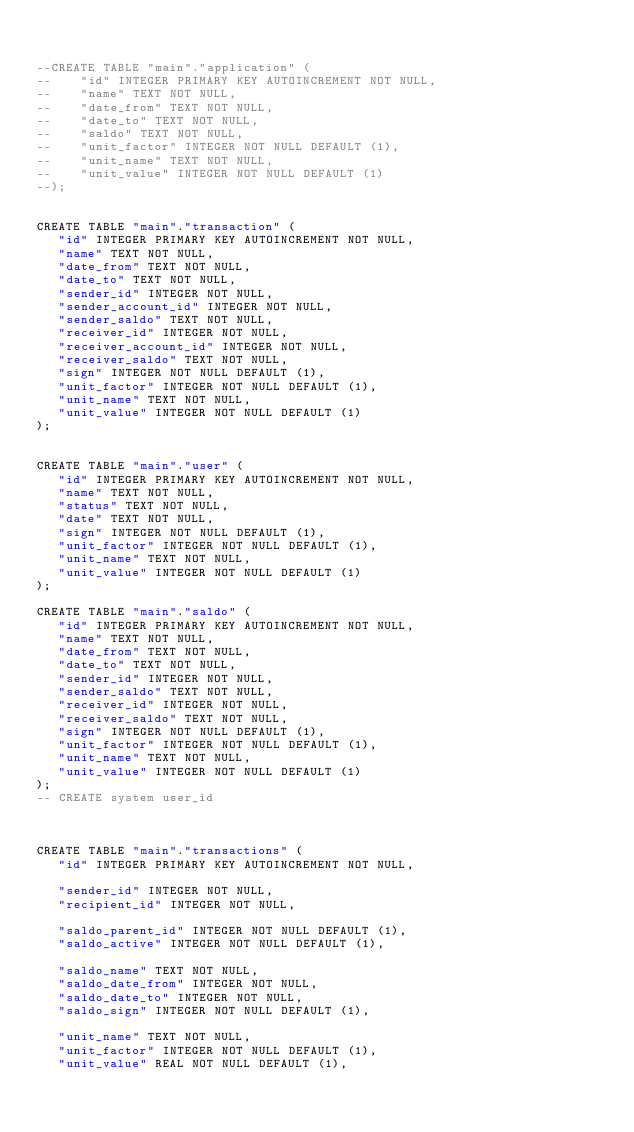Convert code to text. <code><loc_0><loc_0><loc_500><loc_500><_SQL_>

--CREATE TABLE "main"."application" (
--    "id" INTEGER PRIMARY KEY AUTOINCREMENT NOT NULL,
--    "name" TEXT NOT NULL,
--    "date_from" TEXT NOT NULL,
--    "date_to" TEXT NOT NULL,
--    "saldo" TEXT NOT NULL,
--    "unit_factor" INTEGER NOT NULL DEFAULT (1),
--    "unit_name" TEXT NOT NULL,
--    "unit_value" INTEGER NOT NULL DEFAULT (1)
--);


CREATE TABLE "main"."transaction" (
   "id" INTEGER PRIMARY KEY AUTOINCREMENT NOT NULL,
   "name" TEXT NOT NULL,
   "date_from" TEXT NOT NULL,
   "date_to" TEXT NOT NULL,
   "sender_id" INTEGER NOT NULL,
   "sender_account_id" INTEGER NOT NULL,
   "sender_saldo" TEXT NOT NULL,
   "receiver_id" INTEGER NOT NULL,
   "receiver_account_id" INTEGER NOT NULL,
   "receiver_saldo" TEXT NOT NULL,
   "sign" INTEGER NOT NULL DEFAULT (1),
   "unit_factor" INTEGER NOT NULL DEFAULT (1),
   "unit_name" TEXT NOT NULL,
   "unit_value" INTEGER NOT NULL DEFAULT (1)
);


CREATE TABLE "main"."user" (
   "id" INTEGER PRIMARY KEY AUTOINCREMENT NOT NULL,
   "name" TEXT NOT NULL,
   "status" TEXT NOT NULL,
   "date" TEXT NOT NULL,
   "sign" INTEGER NOT NULL DEFAULT (1),
   "unit_factor" INTEGER NOT NULL DEFAULT (1),
   "unit_name" TEXT NOT NULL,
   "unit_value" INTEGER NOT NULL DEFAULT (1)
);

CREATE TABLE "main"."saldo" (
   "id" INTEGER PRIMARY KEY AUTOINCREMENT NOT NULL,
   "name" TEXT NOT NULL,
   "date_from" TEXT NOT NULL,
   "date_to" TEXT NOT NULL,
   "sender_id" INTEGER NOT NULL,
   "sender_saldo" TEXT NOT NULL,
   "receiver_id" INTEGER NOT NULL,
   "receiver_saldo" TEXT NOT NULL,
   "sign" INTEGER NOT NULL DEFAULT (1),
   "unit_factor" INTEGER NOT NULL DEFAULT (1),
   "unit_name" TEXT NOT NULL,
   "unit_value" INTEGER NOT NULL DEFAULT (1)
);
-- CREATE system user_id



CREATE TABLE "main"."transactions" (
   "id" INTEGER PRIMARY KEY AUTOINCREMENT NOT NULL,

   "sender_id" INTEGER NOT NULL,
   "recipient_id" INTEGER NOT NULL,

   "saldo_parent_id" INTEGER NOT NULL DEFAULT (1),
   "saldo_active" INTEGER NOT NULL DEFAULT (1),

   "saldo_name" TEXT NOT NULL,
   "saldo_date_from" INTEGER NOT NULL,
   "saldo_date_to" INTEGER NOT NULL,
   "saldo_sign" INTEGER NOT NULL DEFAULT (1),

   "unit_name" TEXT NOT NULL,
   "unit_factor" INTEGER NOT NULL DEFAULT (1),
   "unit_value" REAL NOT NULL DEFAULT (1),
</code> 